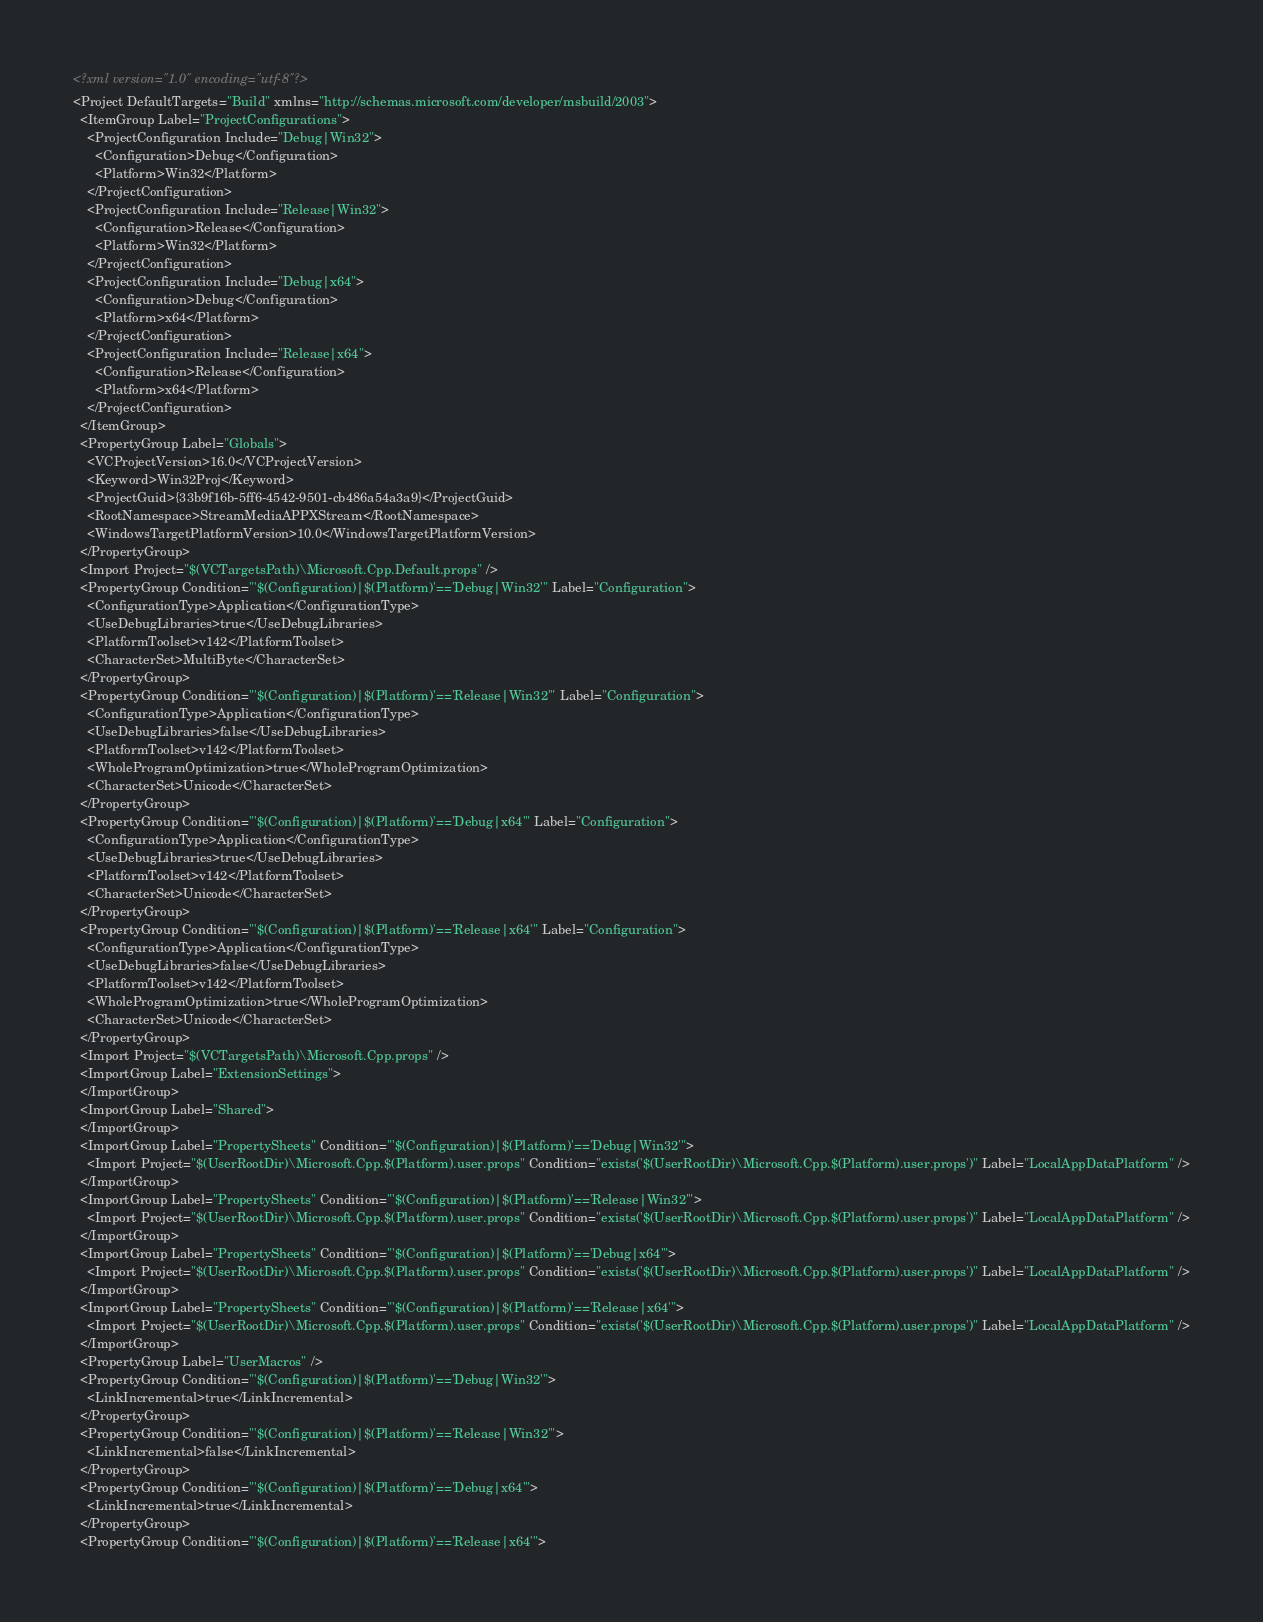<code> <loc_0><loc_0><loc_500><loc_500><_XML_><?xml version="1.0" encoding="utf-8"?>
<Project DefaultTargets="Build" xmlns="http://schemas.microsoft.com/developer/msbuild/2003">
  <ItemGroup Label="ProjectConfigurations">
    <ProjectConfiguration Include="Debug|Win32">
      <Configuration>Debug</Configuration>
      <Platform>Win32</Platform>
    </ProjectConfiguration>
    <ProjectConfiguration Include="Release|Win32">
      <Configuration>Release</Configuration>
      <Platform>Win32</Platform>
    </ProjectConfiguration>
    <ProjectConfiguration Include="Debug|x64">
      <Configuration>Debug</Configuration>
      <Platform>x64</Platform>
    </ProjectConfiguration>
    <ProjectConfiguration Include="Release|x64">
      <Configuration>Release</Configuration>
      <Platform>x64</Platform>
    </ProjectConfiguration>
  </ItemGroup>
  <PropertyGroup Label="Globals">
    <VCProjectVersion>16.0</VCProjectVersion>
    <Keyword>Win32Proj</Keyword>
    <ProjectGuid>{33b9f16b-5ff6-4542-9501-cb486a54a3a9}</ProjectGuid>
    <RootNamespace>StreamMediaAPPXStream</RootNamespace>
    <WindowsTargetPlatformVersion>10.0</WindowsTargetPlatformVersion>
  </PropertyGroup>
  <Import Project="$(VCTargetsPath)\Microsoft.Cpp.Default.props" />
  <PropertyGroup Condition="'$(Configuration)|$(Platform)'=='Debug|Win32'" Label="Configuration">
    <ConfigurationType>Application</ConfigurationType>
    <UseDebugLibraries>true</UseDebugLibraries>
    <PlatformToolset>v142</PlatformToolset>
    <CharacterSet>MultiByte</CharacterSet>
  </PropertyGroup>
  <PropertyGroup Condition="'$(Configuration)|$(Platform)'=='Release|Win32'" Label="Configuration">
    <ConfigurationType>Application</ConfigurationType>
    <UseDebugLibraries>false</UseDebugLibraries>
    <PlatformToolset>v142</PlatformToolset>
    <WholeProgramOptimization>true</WholeProgramOptimization>
    <CharacterSet>Unicode</CharacterSet>
  </PropertyGroup>
  <PropertyGroup Condition="'$(Configuration)|$(Platform)'=='Debug|x64'" Label="Configuration">
    <ConfigurationType>Application</ConfigurationType>
    <UseDebugLibraries>true</UseDebugLibraries>
    <PlatformToolset>v142</PlatformToolset>
    <CharacterSet>Unicode</CharacterSet>
  </PropertyGroup>
  <PropertyGroup Condition="'$(Configuration)|$(Platform)'=='Release|x64'" Label="Configuration">
    <ConfigurationType>Application</ConfigurationType>
    <UseDebugLibraries>false</UseDebugLibraries>
    <PlatformToolset>v142</PlatformToolset>
    <WholeProgramOptimization>true</WholeProgramOptimization>
    <CharacterSet>Unicode</CharacterSet>
  </PropertyGroup>
  <Import Project="$(VCTargetsPath)\Microsoft.Cpp.props" />
  <ImportGroup Label="ExtensionSettings">
  </ImportGroup>
  <ImportGroup Label="Shared">
  </ImportGroup>
  <ImportGroup Label="PropertySheets" Condition="'$(Configuration)|$(Platform)'=='Debug|Win32'">
    <Import Project="$(UserRootDir)\Microsoft.Cpp.$(Platform).user.props" Condition="exists('$(UserRootDir)\Microsoft.Cpp.$(Platform).user.props')" Label="LocalAppDataPlatform" />
  </ImportGroup>
  <ImportGroup Label="PropertySheets" Condition="'$(Configuration)|$(Platform)'=='Release|Win32'">
    <Import Project="$(UserRootDir)\Microsoft.Cpp.$(Platform).user.props" Condition="exists('$(UserRootDir)\Microsoft.Cpp.$(Platform).user.props')" Label="LocalAppDataPlatform" />
  </ImportGroup>
  <ImportGroup Label="PropertySheets" Condition="'$(Configuration)|$(Platform)'=='Debug|x64'">
    <Import Project="$(UserRootDir)\Microsoft.Cpp.$(Platform).user.props" Condition="exists('$(UserRootDir)\Microsoft.Cpp.$(Platform).user.props')" Label="LocalAppDataPlatform" />
  </ImportGroup>
  <ImportGroup Label="PropertySheets" Condition="'$(Configuration)|$(Platform)'=='Release|x64'">
    <Import Project="$(UserRootDir)\Microsoft.Cpp.$(Platform).user.props" Condition="exists('$(UserRootDir)\Microsoft.Cpp.$(Platform).user.props')" Label="LocalAppDataPlatform" />
  </ImportGroup>
  <PropertyGroup Label="UserMacros" />
  <PropertyGroup Condition="'$(Configuration)|$(Platform)'=='Debug|Win32'">
    <LinkIncremental>true</LinkIncremental>
  </PropertyGroup>
  <PropertyGroup Condition="'$(Configuration)|$(Platform)'=='Release|Win32'">
    <LinkIncremental>false</LinkIncremental>
  </PropertyGroup>
  <PropertyGroup Condition="'$(Configuration)|$(Platform)'=='Debug|x64'">
    <LinkIncremental>true</LinkIncremental>
  </PropertyGroup>
  <PropertyGroup Condition="'$(Configuration)|$(Platform)'=='Release|x64'"></code> 